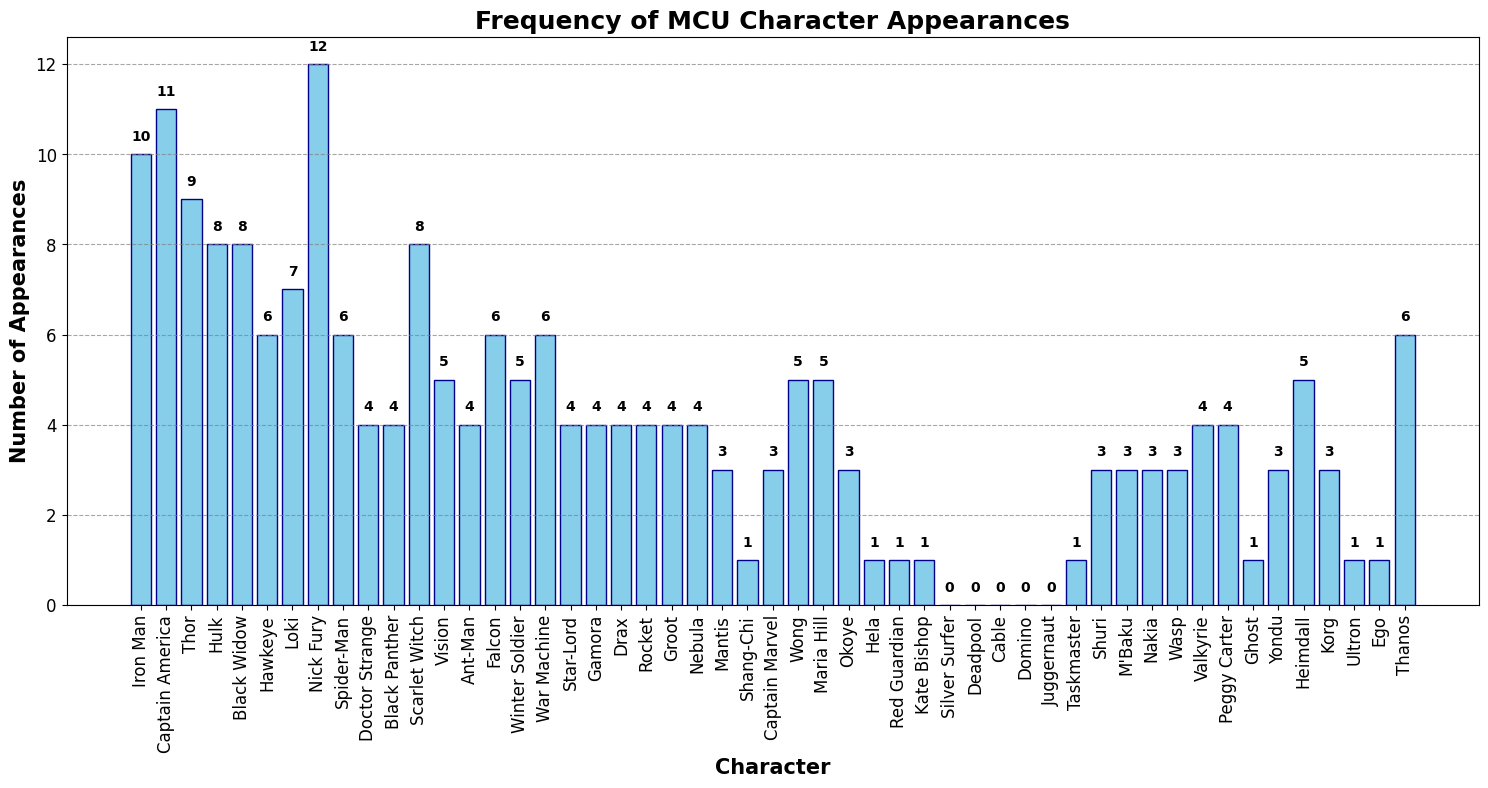Which character has the highest number of appearances? The bar with the highest value represents the character with the most appearances. According to the figure, Nick Fury has the highest number of appearances.
Answer: Nick Fury Who has more appearances: Iron Man or Thor? Compare the height of the bars representing Iron Man and Thor. Iron Man has 10 appearances, while Thor has 9 appearances.
Answer: Iron Man What is the combined total number of appearances for Captain America and Black Widow? Add the appearances of Captain America and Black Widow. Captain America has 11 appearances, and Black Widow has 8 appearances. 11 + 8 = 19.
Answer: 19 How many characters have exactly 4 appearances? Count the number of bars that reach exactly 4 on the y-axis. The characters with 4 appearances are Doctor Strange, Black Panther, Ant-Man, Star-Lord, Gamora, Drax, Rocket, Groot, Nebula, Valkyrie, and Peggy Carter. There are 11 characters in total.
Answer: 11 What is the difference in the number of appearances between Loki and Spider-Man? Subtract the number of appearances of Spider-Man from Loki's appearances. Loki has 7 appearances, and Spider-Man has 6 appearances. 7 - 6 = 1.
Answer: 1 Which character has the lowest number of appearances, and how many do they have? Look for the bars with the lowest height. Characters with the lowest height have 0 appearances. They are Silver Surfer, Deadpool, Cable, Domino, and Juggernaut.
Answer: Silver Surfer, Deadpool, Cable, Domino, Juggernaut - 0 How much taller is the bar for Hulk compared to the bar for Ant-Man? Find the height difference between the bars for Hulk and Ant-Man. Hulk has 8 appearances, and Ant-Man has 4 appearances. 8 - 4 = 4.
Answer: 4 If we average the number of appearances of the main Avengers (Iron Man, Captain America, Thor, Hulk, Black Widow, and Hawkeye), what is the result? Calculate the average appearances: (10 + 11 + 9 + 8 + 8 + 6) / 6 = 52 / 6 ≈ 8.67.
Answer: 8.67 Who has a greater number of appearances: Vision or Wong? Compare the height of the bars representing Vision and Wong. Vision has 5 appearances, while Wong has 5 appearances as well. They are equal.
Answer: They are equal 